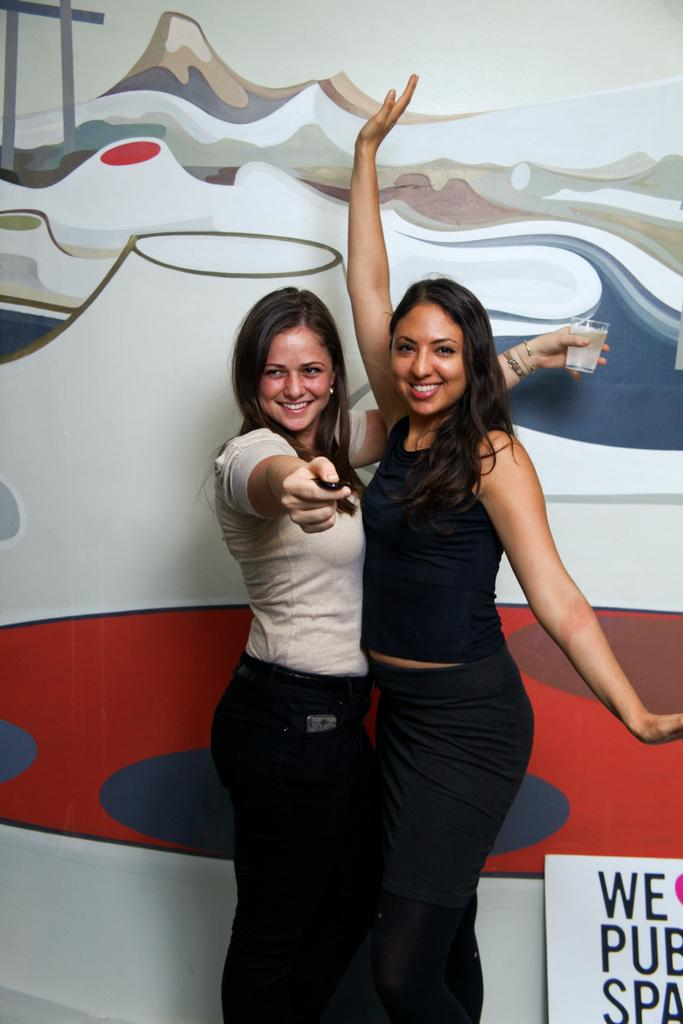How many women are in the image? There are two women standing in the middle of the image. What is the facial expression of the women? Both women are smiling. What is one woman holding in the image? One woman is holding a glass. What can be seen in the background of the image? There is a board in the background of the image, and the wall is painted. How does the wind affect the size of the women's brains in the image? There is no mention of wind or the size of the women's brains in the image, so this question cannot be answered definitively. 